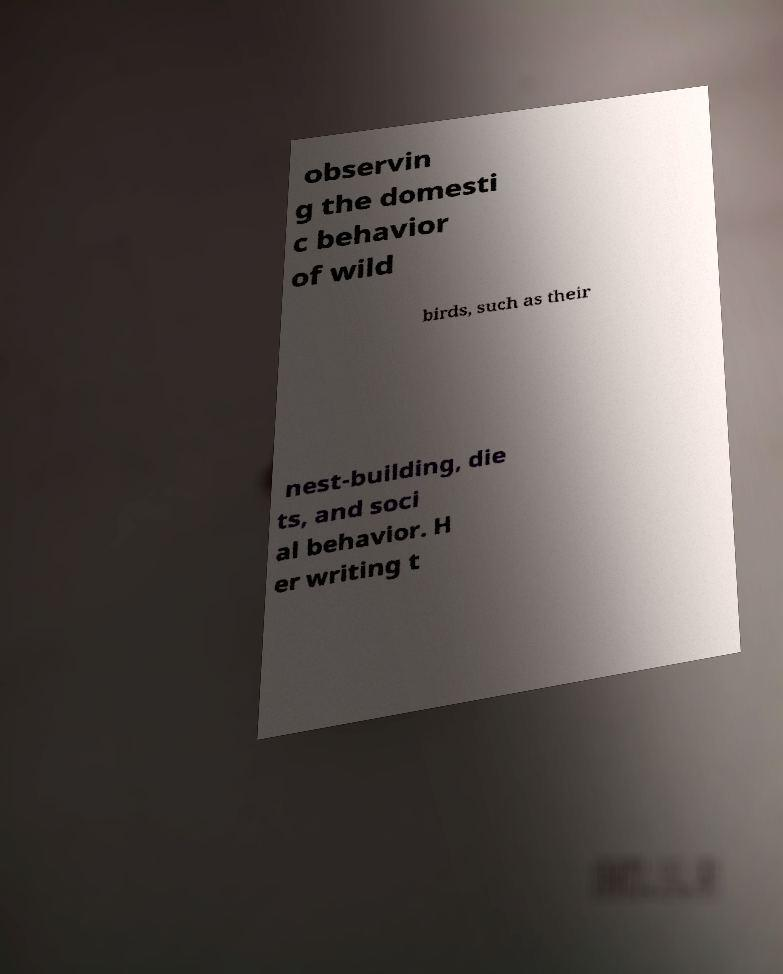There's text embedded in this image that I need extracted. Can you transcribe it verbatim? observin g the domesti c behavior of wild birds, such as their nest-building, die ts, and soci al behavior. H er writing t 